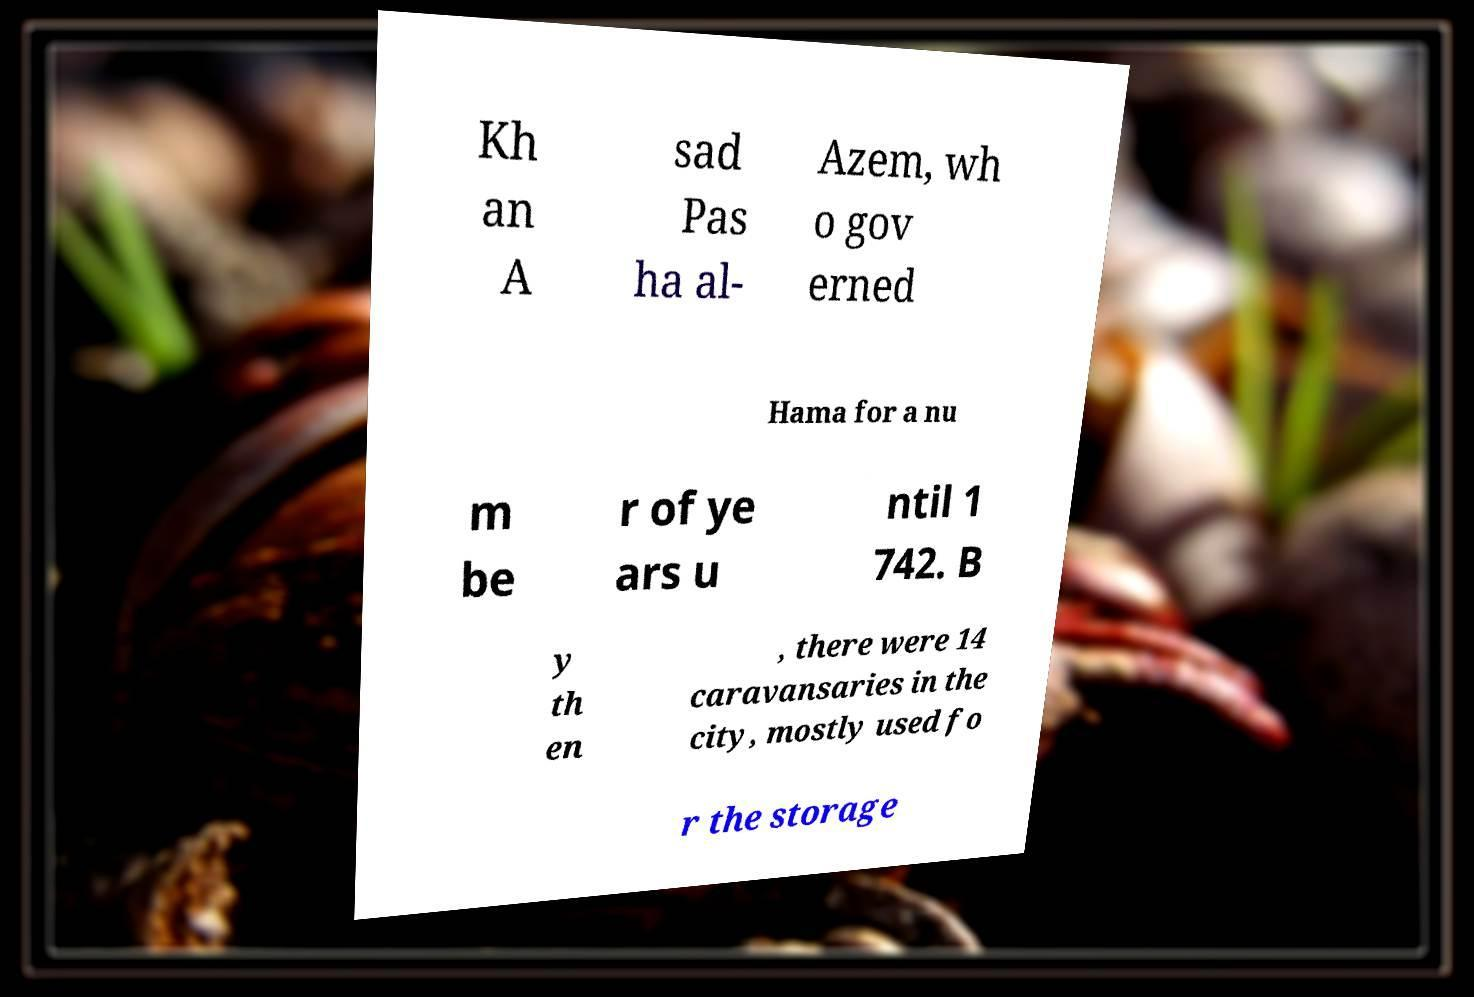Please identify and transcribe the text found in this image. Kh an A sad Pas ha al- Azem, wh o gov erned Hama for a nu m be r of ye ars u ntil 1 742. B y th en , there were 14 caravansaries in the city, mostly used fo r the storage 